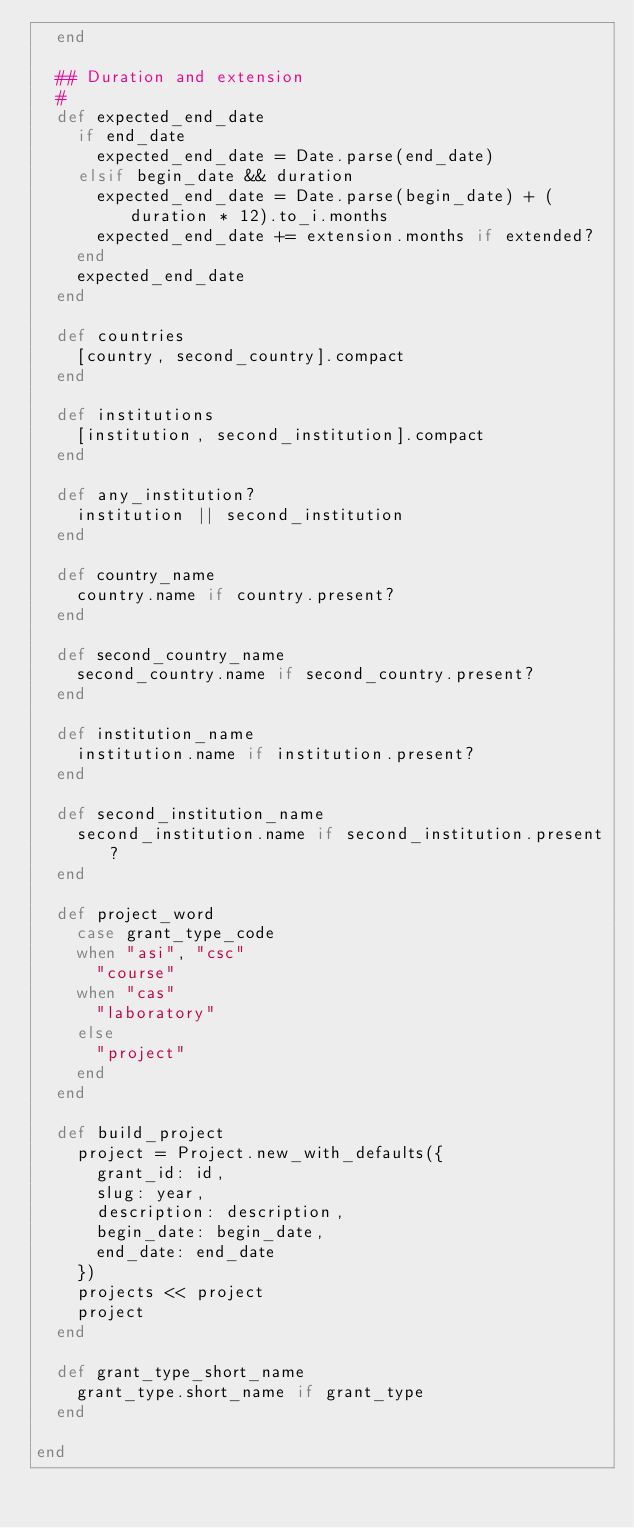Convert code to text. <code><loc_0><loc_0><loc_500><loc_500><_Ruby_>  end

  ## Duration and extension
  #
  def expected_end_date
    if end_date
      expected_end_date = Date.parse(end_date)
    elsif begin_date && duration
      expected_end_date = Date.parse(begin_date) + (duration * 12).to_i.months
      expected_end_date += extension.months if extended?
    end
    expected_end_date
  end
  
  def countries
    [country, second_country].compact
  end

  def institutions
    [institution, second_institution].compact
  end
  
  def any_institution?
    institution || second_institution
  end

  def country_name
    country.name if country.present?
  end

  def second_country_name
    second_country.name if second_country.present?
  end

  def institution_name
    institution.name if institution.present?
  end

  def second_institution_name
    second_institution.name if second_institution.present?
  end

  def project_word
    case grant_type_code
    when "asi", "csc"
      "course"
    when "cas"
      "laboratory"
    else
      "project"
    end
  end

  def build_project
    project = Project.new_with_defaults({
      grant_id: id,
      slug: year,
      description: description,
      begin_date: begin_date,
      end_date: end_date
    })
    projects << project
    project
  end
  
  def grant_type_short_name
    grant_type.short_name if grant_type
  end

end
</code> 